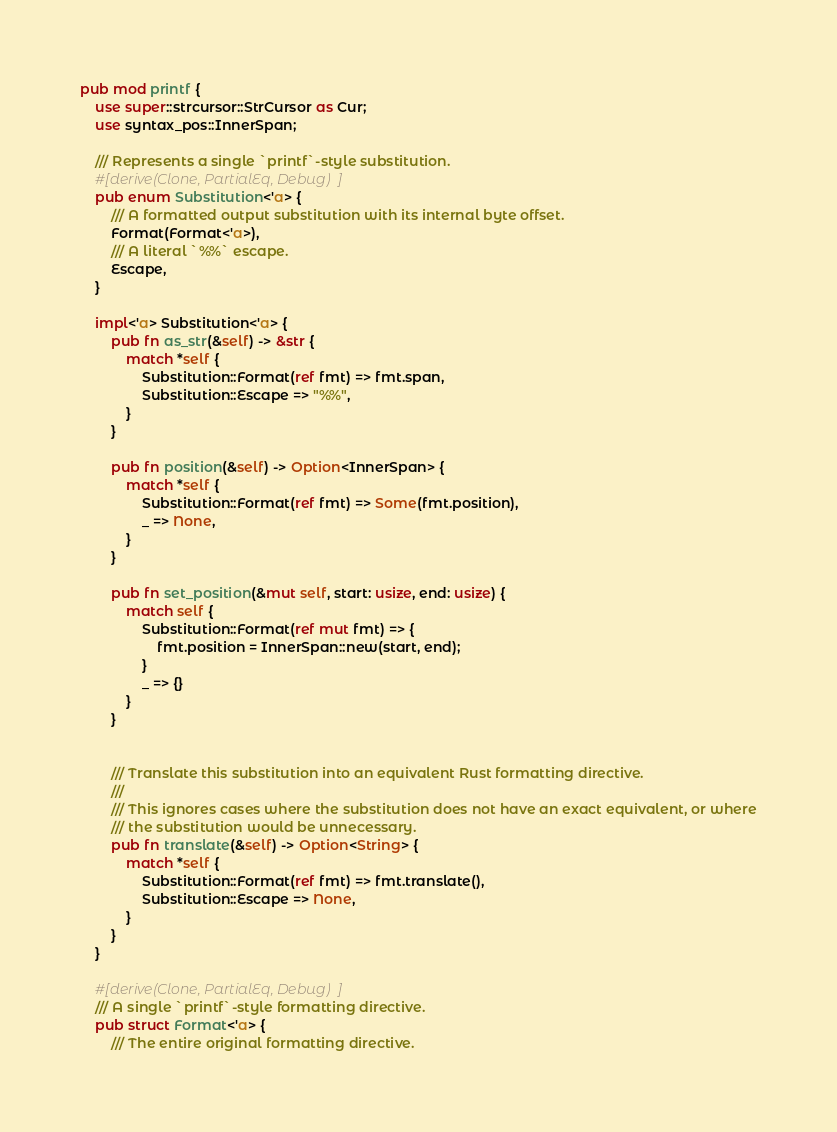<code> <loc_0><loc_0><loc_500><loc_500><_Rust_>pub mod printf {
    use super::strcursor::StrCursor as Cur;
    use syntax_pos::InnerSpan;

    /// Represents a single `printf`-style substitution.
    #[derive(Clone, PartialEq, Debug)]
    pub enum Substitution<'a> {
        /// A formatted output substitution with its internal byte offset.
        Format(Format<'a>),
        /// A literal `%%` escape.
        Escape,
    }

    impl<'a> Substitution<'a> {
        pub fn as_str(&self) -> &str {
            match *self {
                Substitution::Format(ref fmt) => fmt.span,
                Substitution::Escape => "%%",
            }
        }

        pub fn position(&self) -> Option<InnerSpan> {
            match *self {
                Substitution::Format(ref fmt) => Some(fmt.position),
                _ => None,
            }
        }

        pub fn set_position(&mut self, start: usize, end: usize) {
            match self {
                Substitution::Format(ref mut fmt) => {
                    fmt.position = InnerSpan::new(start, end);
                }
                _ => {}
            }
        }


        /// Translate this substitution into an equivalent Rust formatting directive.
        ///
        /// This ignores cases where the substitution does not have an exact equivalent, or where
        /// the substitution would be unnecessary.
        pub fn translate(&self) -> Option<String> {
            match *self {
                Substitution::Format(ref fmt) => fmt.translate(),
                Substitution::Escape => None,
            }
        }
    }

    #[derive(Clone, PartialEq, Debug)]
    /// A single `printf`-style formatting directive.
    pub struct Format<'a> {
        /// The entire original formatting directive.</code> 